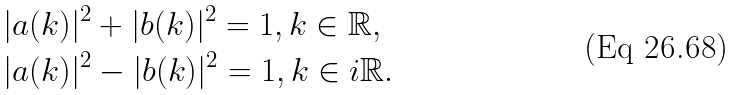<formula> <loc_0><loc_0><loc_500><loc_500>& | a ( k ) | ^ { 2 } + | b ( k ) | ^ { 2 } = 1 , k \in \mathbb { R } , \\ & | a ( k ) | ^ { 2 } - | b ( k ) | ^ { 2 } = 1 , k \in i \mathbb { R } .</formula> 